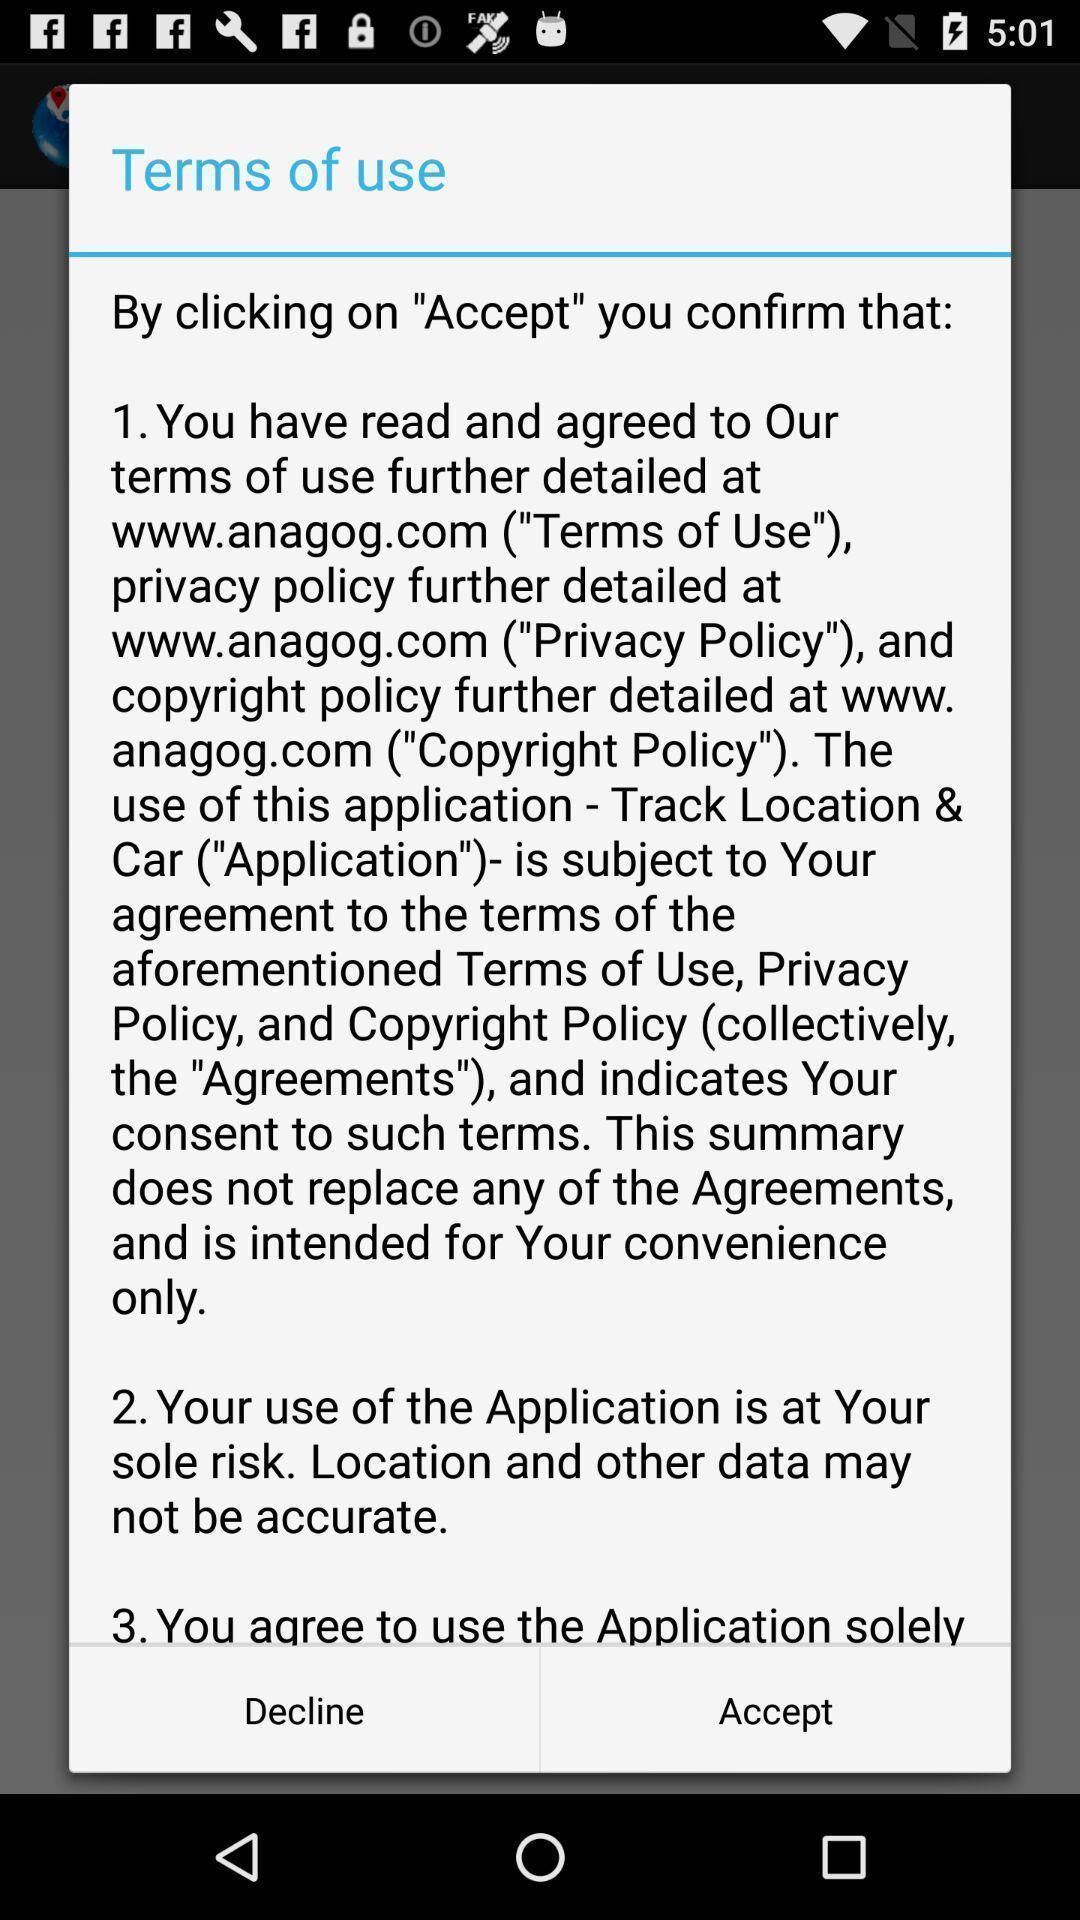Tell me about the visual elements in this screen capture. Pop-up for accepting terms of use of the application. 